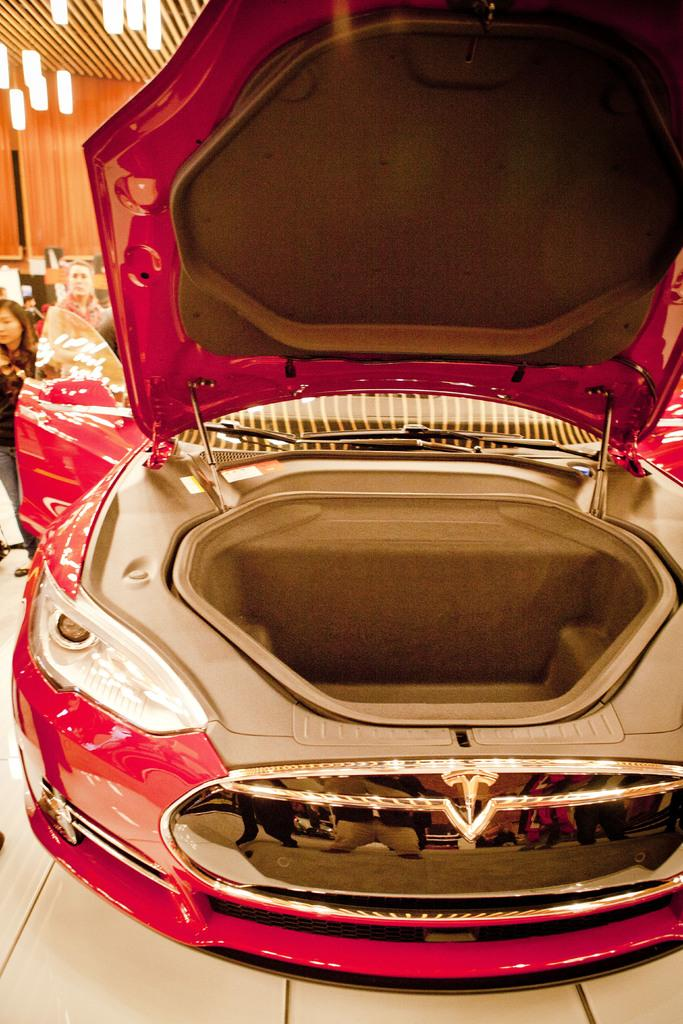What part of a vehicle can be seen in the image? The trunk of a car is visible in the image. Who or what is present in the image besides the car trunk? There are people standing in the image. Where are the people standing in relation to the car trunk? The people are standing on the floor. What type of lighting is present in the image? Electric lights are hanging from the top in the image. What type of stick can be seen in the image? There is no stick present in the image. Where is the recess located in the image? There is no recess present in the image. 